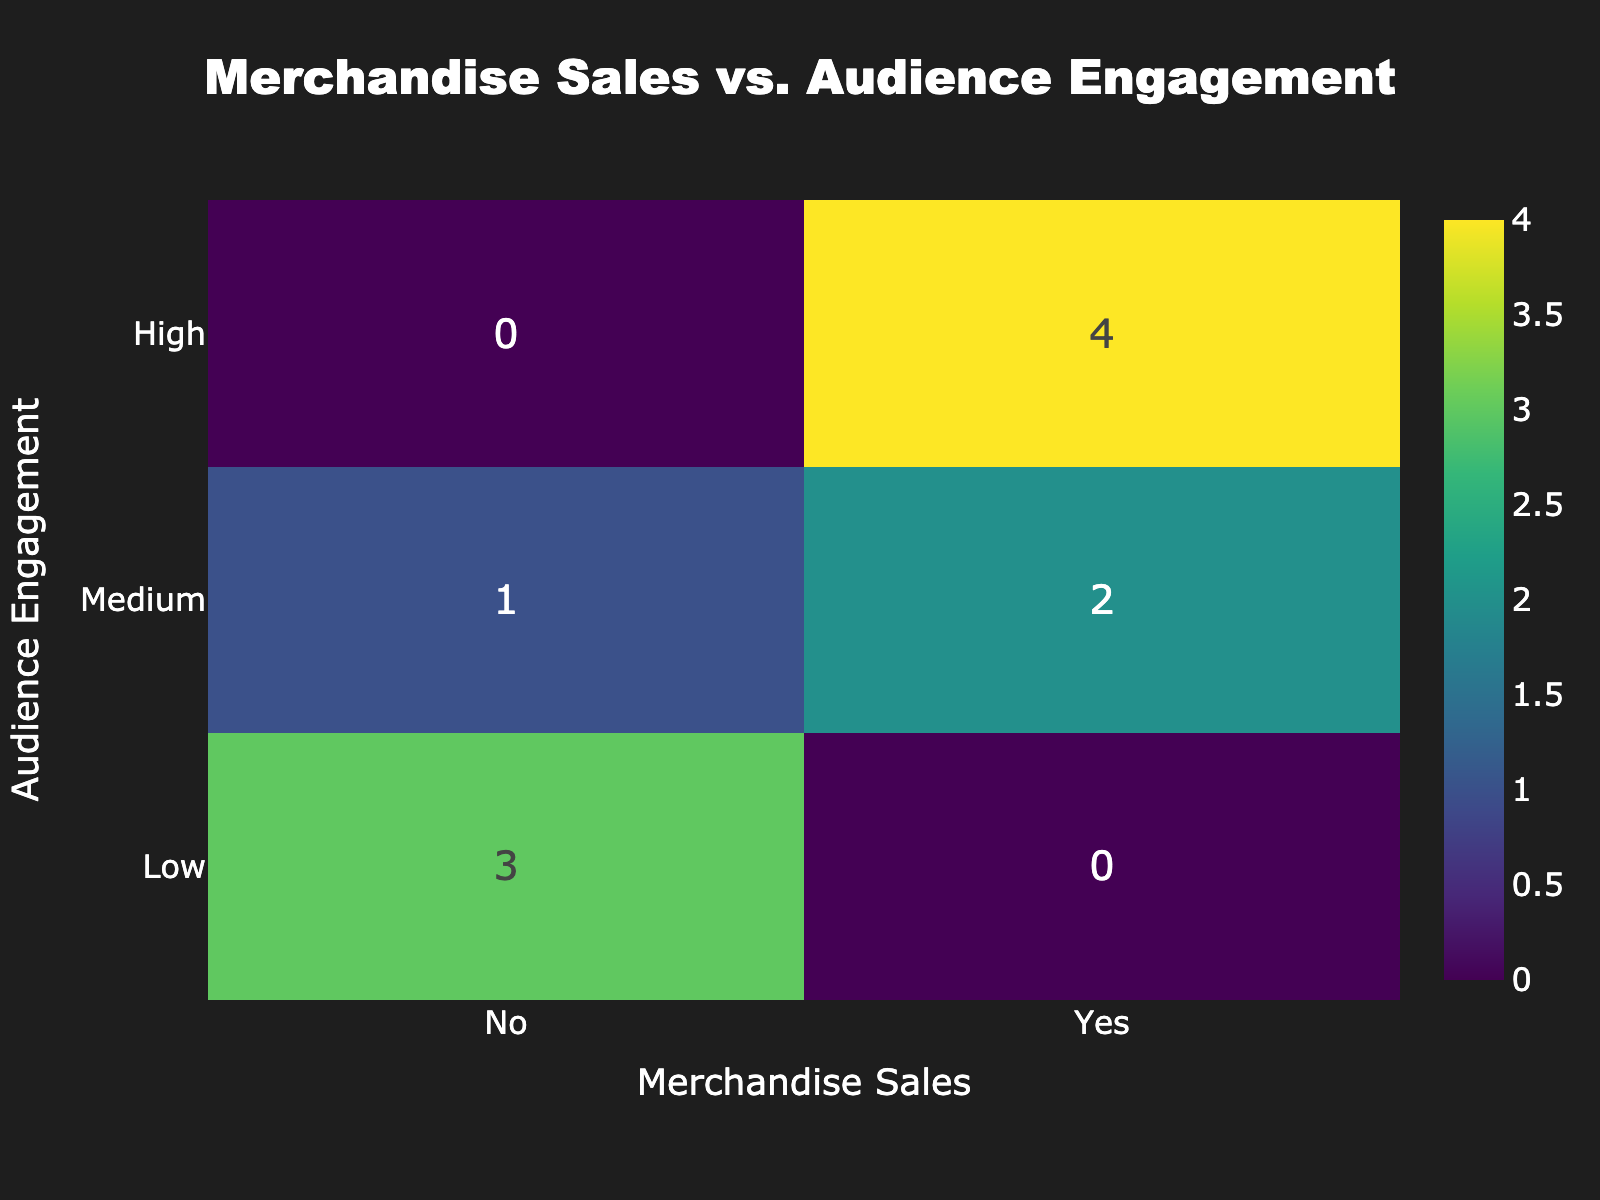What is the total number of events with high audience engagement? There are three events labeled as having high audience engagement, namely Metallica 2023, Slipknot 2023, and Judas Priest 2023.
Answer: 3 How many events had low audience engagement and resulted in merchandise sales? Looking at the table, the events with low audience engagement (Black Sabbath Reunion, Pantera 2023, and Motorhead Tribute) resulted in no merchandise sales. Therefore, the count of such events is zero.
Answer: 0 What is the percentage of medium engagement events that had merchandise sales? There are three events categorized as medium engagement (Iron Maiden 2023, Megadeth 2023, and System of a Down 2023). Out of these, only one event (System of a Down 2023) had sales. The percentage is (1/3) * 100 = 33.33%.
Answer: 33.33% Did any high engagement event have no merchandise sales? All events with high audience engagement, which include Metallica 2023, Slipknot 2023, and Judas Priest 2023, had merchandise sales, thus responding negatively to this question.
Answer: No What is the total number of events that had merchandise sales? Reviewing the data, the events that had merchandise sales are Metallica 2023, Iron Maiden 2023, Slipknot 2023, Judas Priest 2023, System of a Down 2023, and Nightwish 2023, which totals six events.
Answer: 6 How does low audience engagement correlate with merchandise sales based on the data? With low audience engagement, there are three events (Black Sabbath Reunion, Pantera 2023, and Motorhead Tribute), and all three resulted in no merchandise sales. This indicates a negative correlation.
Answer: Negative correlation How many total events were analyzed in this dataset? The dataset provides a total of ten events (from Metallica 2023 to Nightwish 2023). Thus, the total number of analyzed events is ten.
Answer: 10 What is the ratio of high engagement events to those with no merchandise sales? There are four high engagement events (Metallica 2023, Slipknot 2023, Judas Priest 2023, and Nightwish 2023) and four events with no merchandise sales (Black Sabbath Reunion, Megadeth 2023, Pantera 2023, and Motorhead Tribute). Therefore, the ratio of high engagement events to no sales is 4:4 or simplified, 1:1.
Answer: 1:1 In total, how many events were marked as medium engagement and had no merchandise sales? From the dataset, there are three medium engagement events (Iron Maiden 2023, Megadeth 2023, and System of a Down 2023). Only one of these, Megadeth 2023, resulted in no merchandise sales. Thus, there is one event that fits this criterion.
Answer: 1 